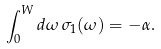<formula> <loc_0><loc_0><loc_500><loc_500>\int _ { 0 } ^ { W } d \omega \, \sigma _ { 1 } ( \omega ) = - \alpha .</formula> 